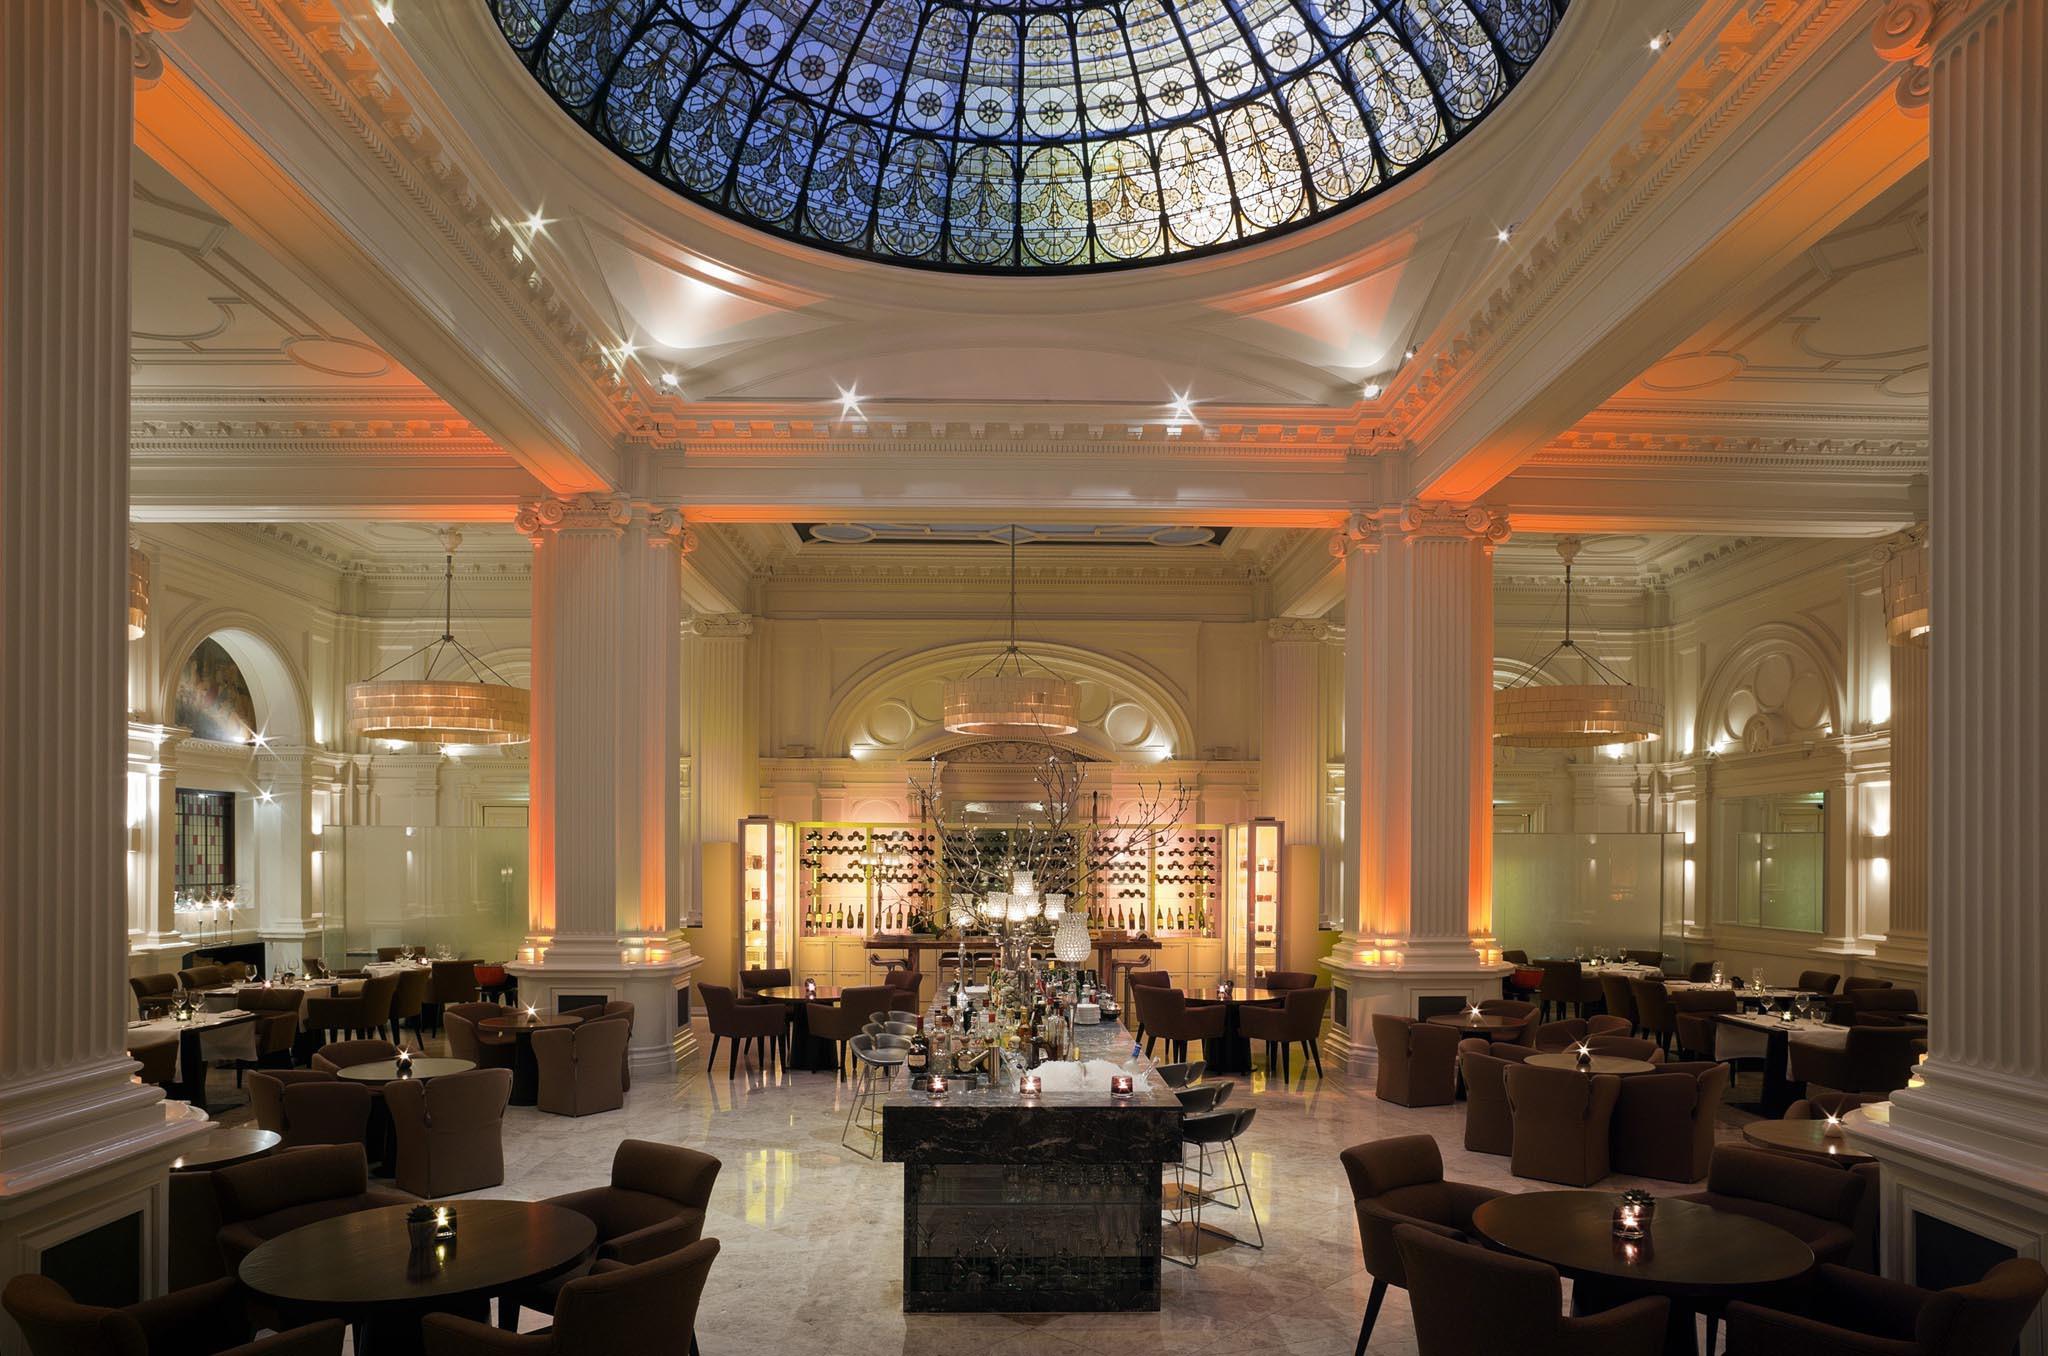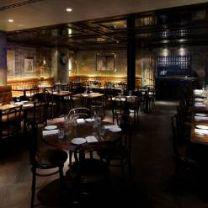The first image is the image on the left, the second image is the image on the right. Examine the images to the left and right. Is the description "An interior of a restaurant has yellow tufted bench seating around its perimeter and has a view of a staircase glowing violet and blue above the seating on the right." accurate? Answer yes or no. No. The first image is the image on the left, the second image is the image on the right. For the images shown, is this caption "Each image shows an empty restaurant with no people visible." true? Answer yes or no. Yes. 